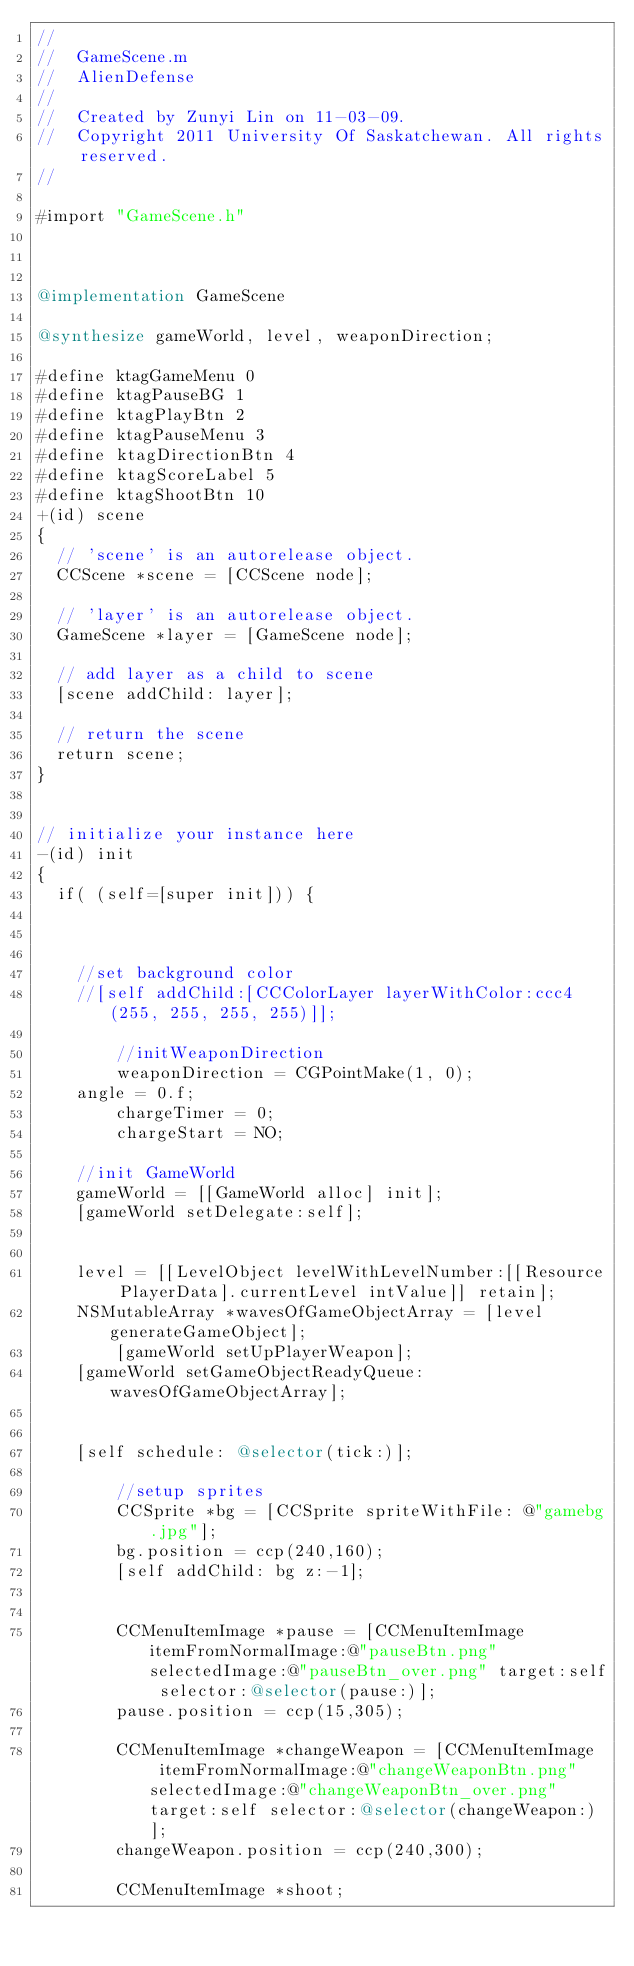<code> <loc_0><loc_0><loc_500><loc_500><_ObjectiveC_>//
//  GameScene.m
//  AlienDefense
//
//  Created by Zunyi Lin on 11-03-09.
//  Copyright 2011 University Of Saskatchewan. All rights reserved.
//

#import "GameScene.h"



@implementation GameScene

@synthesize gameWorld, level, weaponDirection;

#define ktagGameMenu 0
#define ktagPauseBG 1
#define ktagPlayBtn 2
#define ktagPauseMenu 3
#define ktagDirectionBtn 4
#define ktagScoreLabel 5
#define ktagShootBtn 10
+(id) scene
{
	// 'scene' is an autorelease object.
	CCScene *scene = [CCScene node];
	
	// 'layer' is an autorelease object.
	GameScene *layer = [GameScene node];
	
	// add layer as a child to scene
	[scene addChild: layer];
	
	// return the scene
	return scene;
}


// initialize your instance here
-(id) init
{
	if( (self=[super init])) {
		

		
		//set background color
		//[self addChild:[CCColorLayer layerWithColor:ccc4(255, 255, 255, 255)]];
		
        //initWeaponDirection
        weaponDirection = CGPointMake(1, 0);
		angle = 0.f;
        chargeTimer = 0;
        chargeStart = NO;
        
		//init GameWorld
		gameWorld = [[GameWorld alloc] init];
		[gameWorld setDelegate:self];
        
        
		level = [[LevelObject levelWithLevelNumber:[[Resource PlayerData].currentLevel intValue]] retain];
		NSMutableArray *wavesOfGameObjectArray = [level generateGameObject];
        [gameWorld setUpPlayerWeapon];
		[gameWorld setGameObjectReadyQueue: wavesOfGameObjectArray];
		
        
		[self schedule: @selector(tick:)];
        
        //setup sprites
        CCSprite *bg = [CCSprite spriteWithFile: @"gamebg.jpg"];
        bg.position = ccp(240,160);
        [self addChild: bg z:-1];
        
        
        CCMenuItemImage *pause = [CCMenuItemImage  itemFromNormalImage:@"pauseBtn.png" selectedImage:@"pauseBtn_over.png" target:self selector:@selector(pause:)];
        pause.position = ccp(15,305);
        
        CCMenuItemImage *changeWeapon = [CCMenuItemImage  itemFromNormalImage:@"changeWeaponBtn.png" selectedImage:@"changeWeaponBtn_over.png" target:self selector:@selector(changeWeapon:)];
        changeWeapon.position = ccp(240,300);
        
        CCMenuItemImage *shoot;</code> 